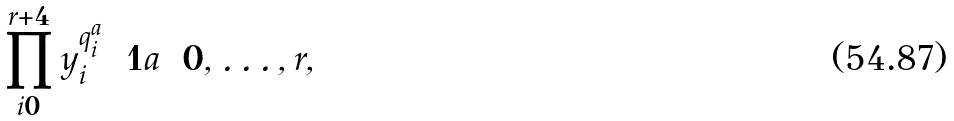Convert formula to latex. <formula><loc_0><loc_0><loc_500><loc_500>\prod _ { i = 0 } ^ { r + 4 } y _ { i } ^ { q _ { i } ^ { a } } = 1 a = 0 , \dots , r ,</formula> 